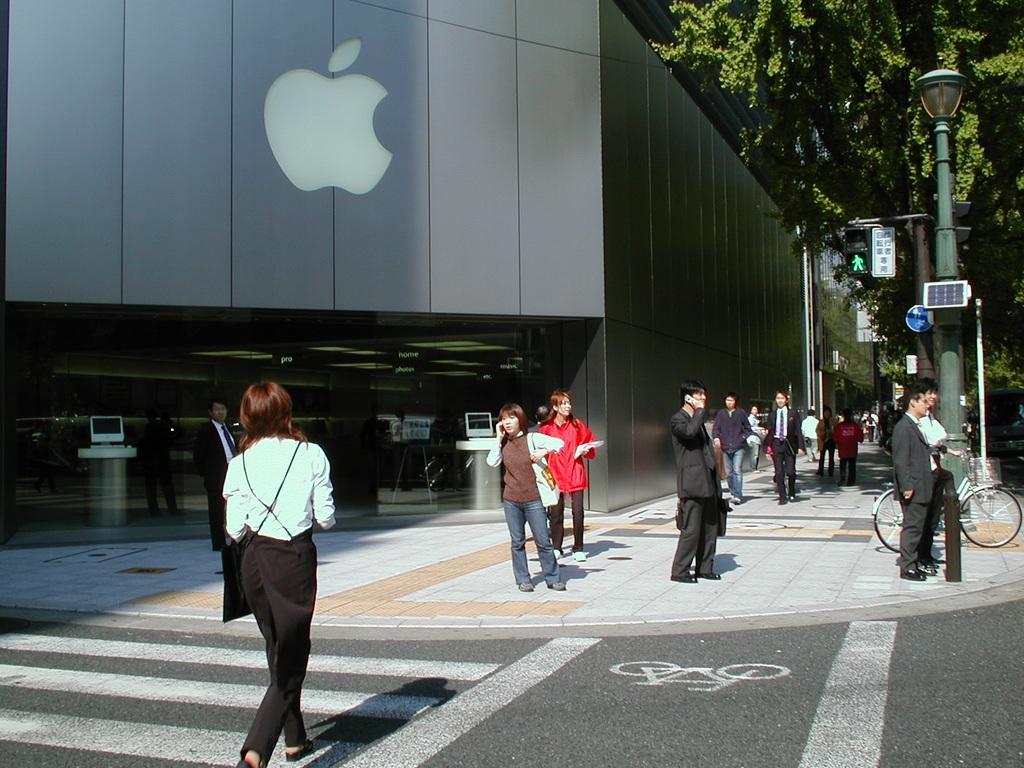In one or two sentences, can you explain what this image depicts? In this image there are group of persons standing and walking. On the right side there is a pole and there are trees. On the left side there is a building, and on the wall of the building there is a symbol of an apple. 